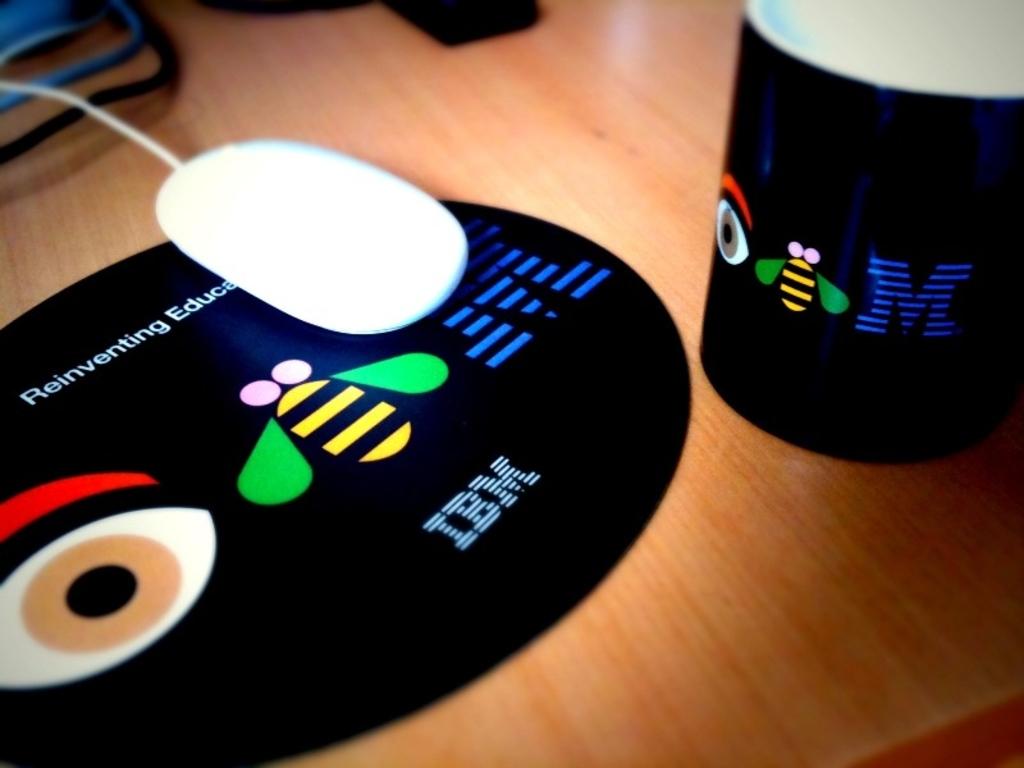Who manufactured the mouse pad?
Make the answer very short. Ibm. What is the right letter on the mouse pad?
Your response must be concise. M. 